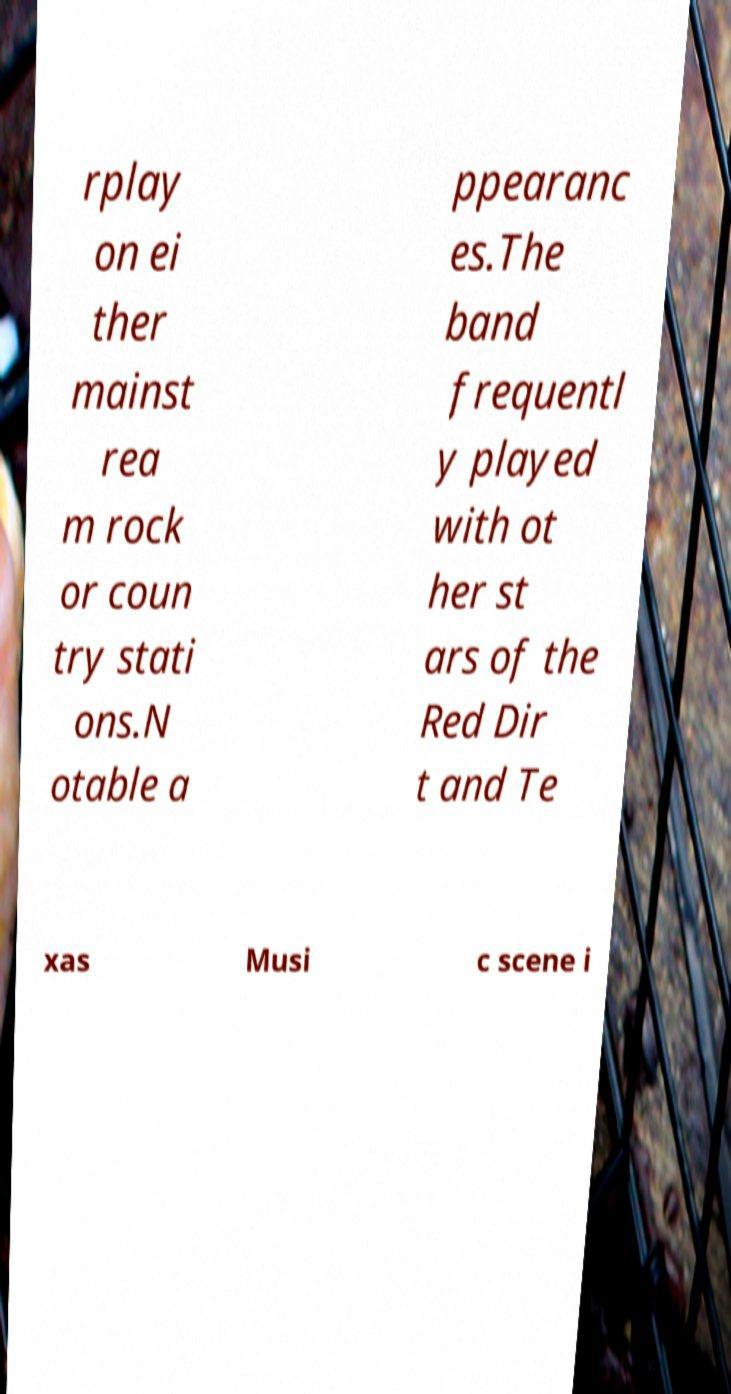Can you read and provide the text displayed in the image?This photo seems to have some interesting text. Can you extract and type it out for me? rplay on ei ther mainst rea m rock or coun try stati ons.N otable a ppearanc es.The band frequentl y played with ot her st ars of the Red Dir t and Te xas Musi c scene i 